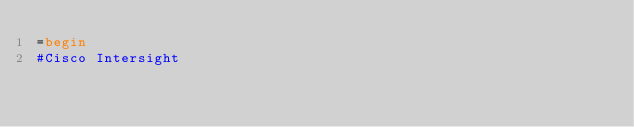Convert code to text. <code><loc_0><loc_0><loc_500><loc_500><_Ruby_>=begin
#Cisco Intersight
</code> 